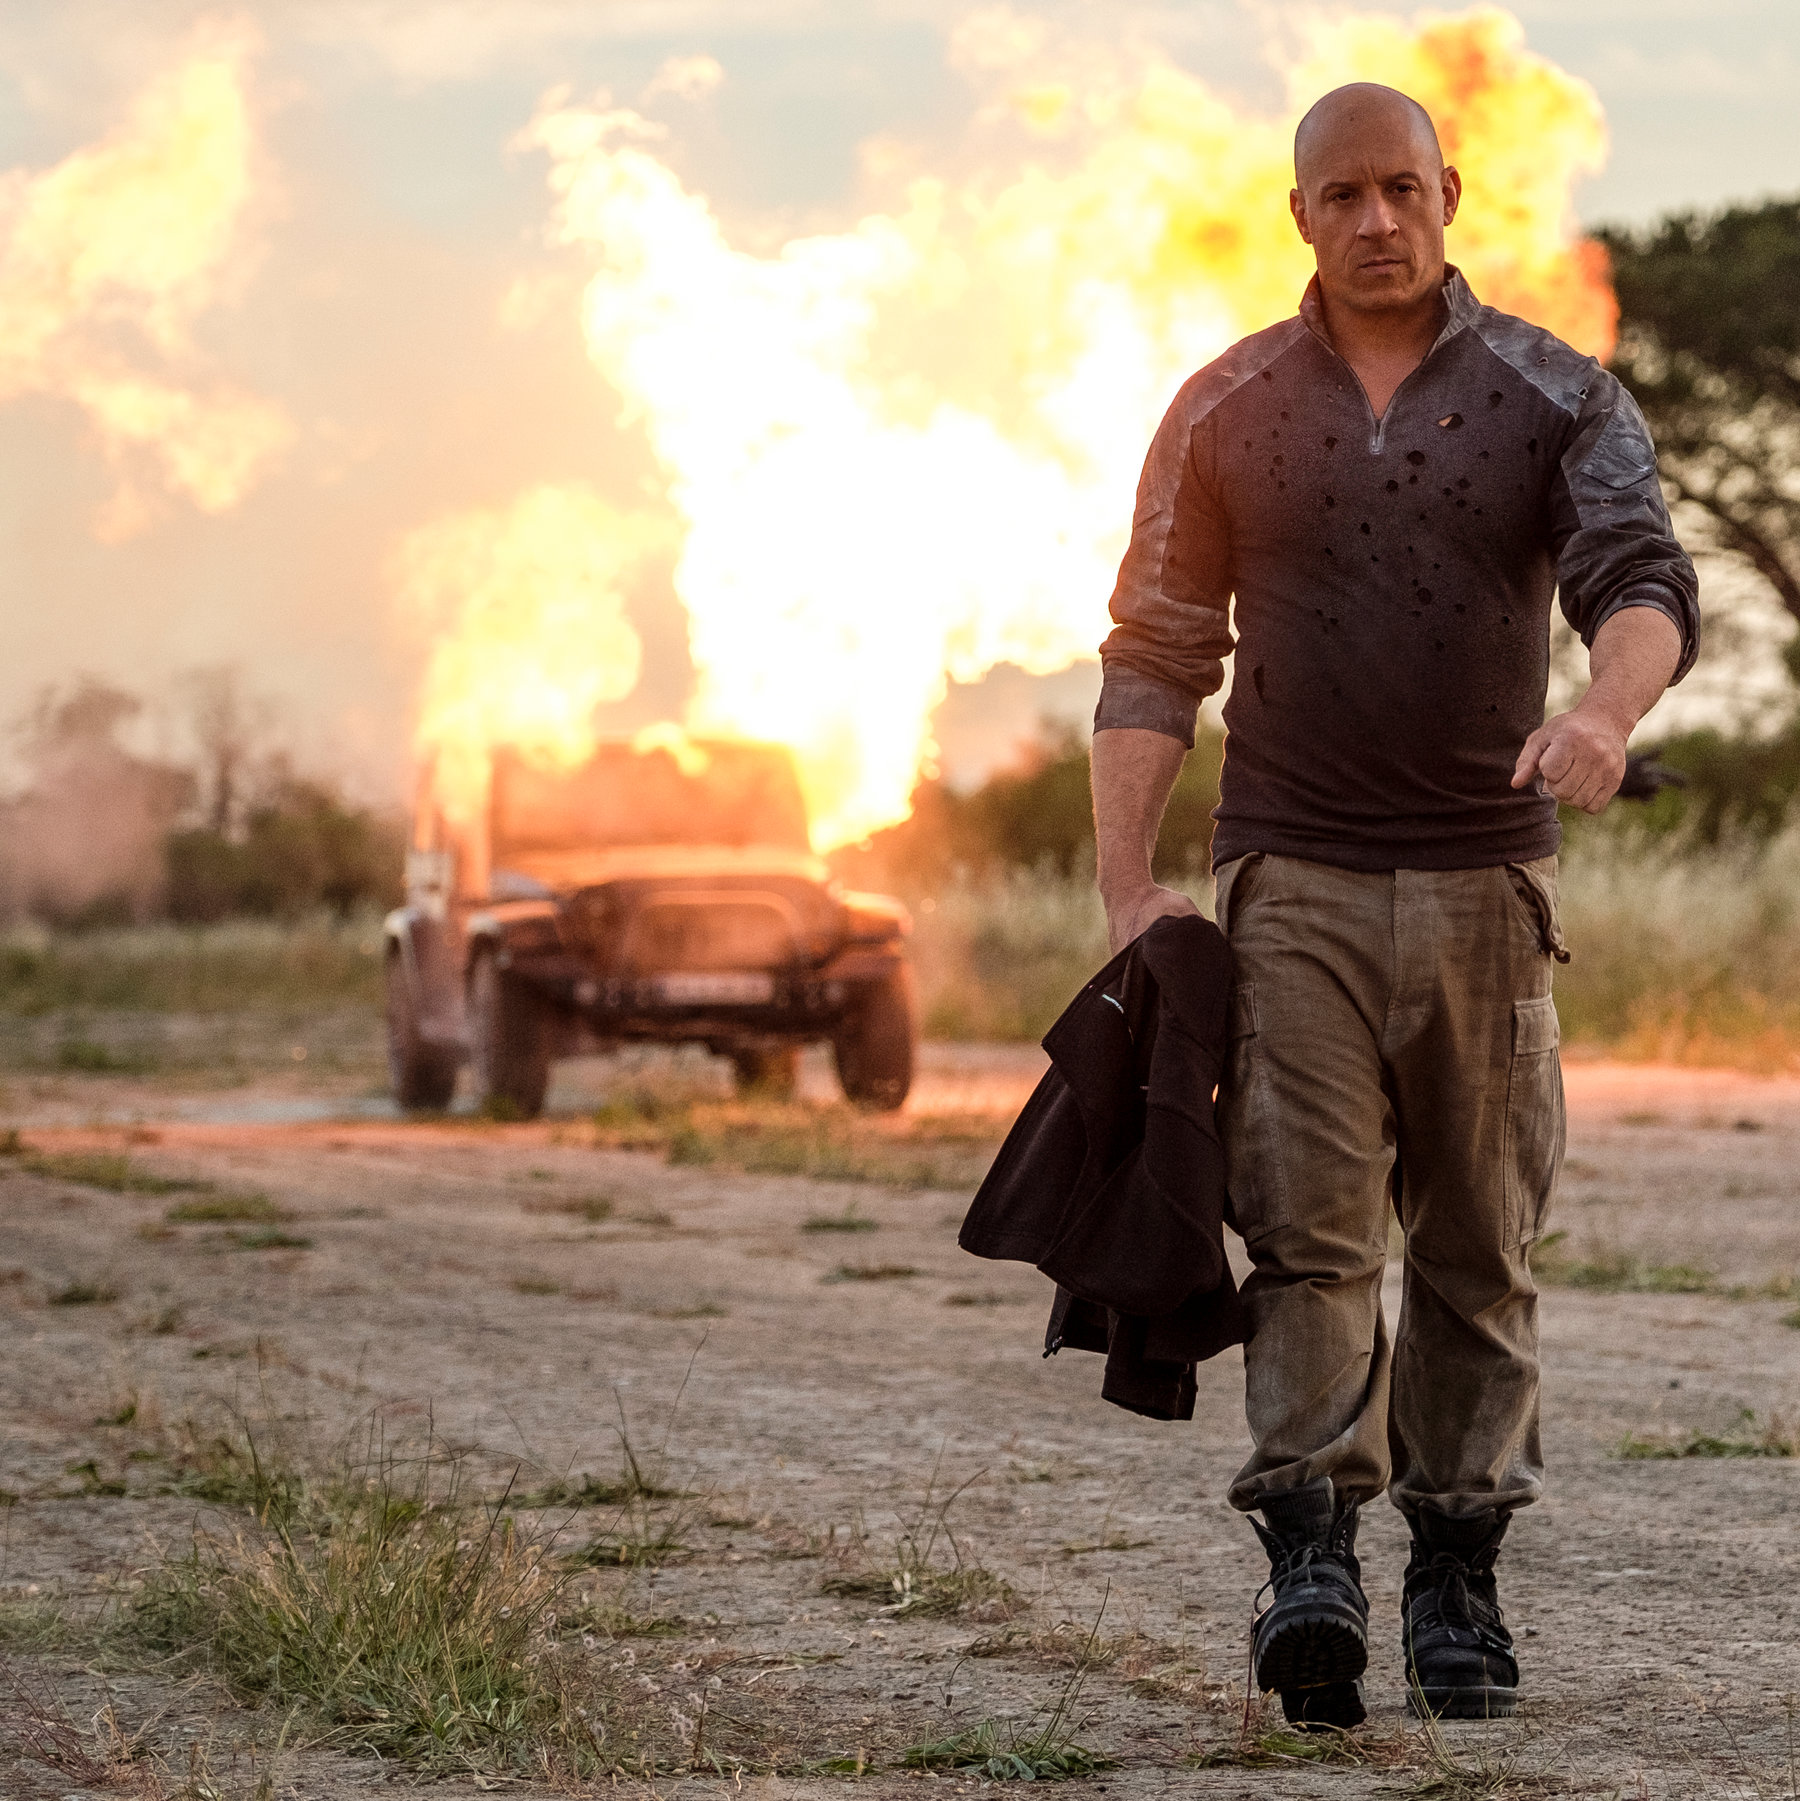What time of day does this scene represent, and how can you tell? The scene appears to be set around sunset, as indicated by the orange and red tones in the sky, which are typical of the natural lighting conditions during that time of day. The light casts long shadows and gives a warm glow to the surroundings. 